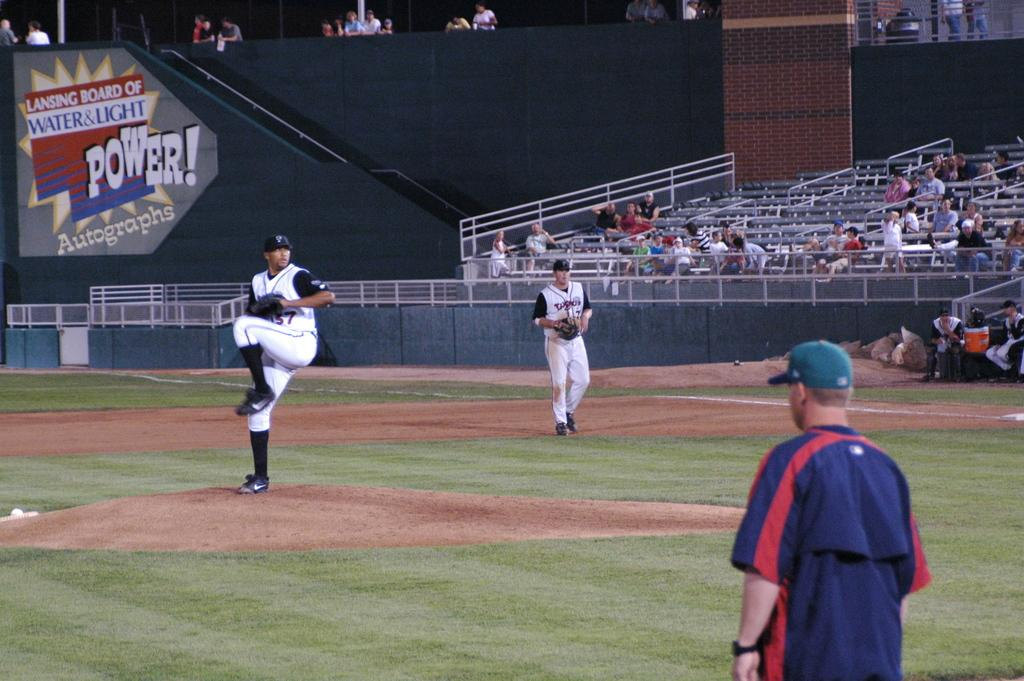<image>
Relay a brief, clear account of the picture shown. A message on the side of the stairs that say Lansing Board of Water & Light Power Autographs 